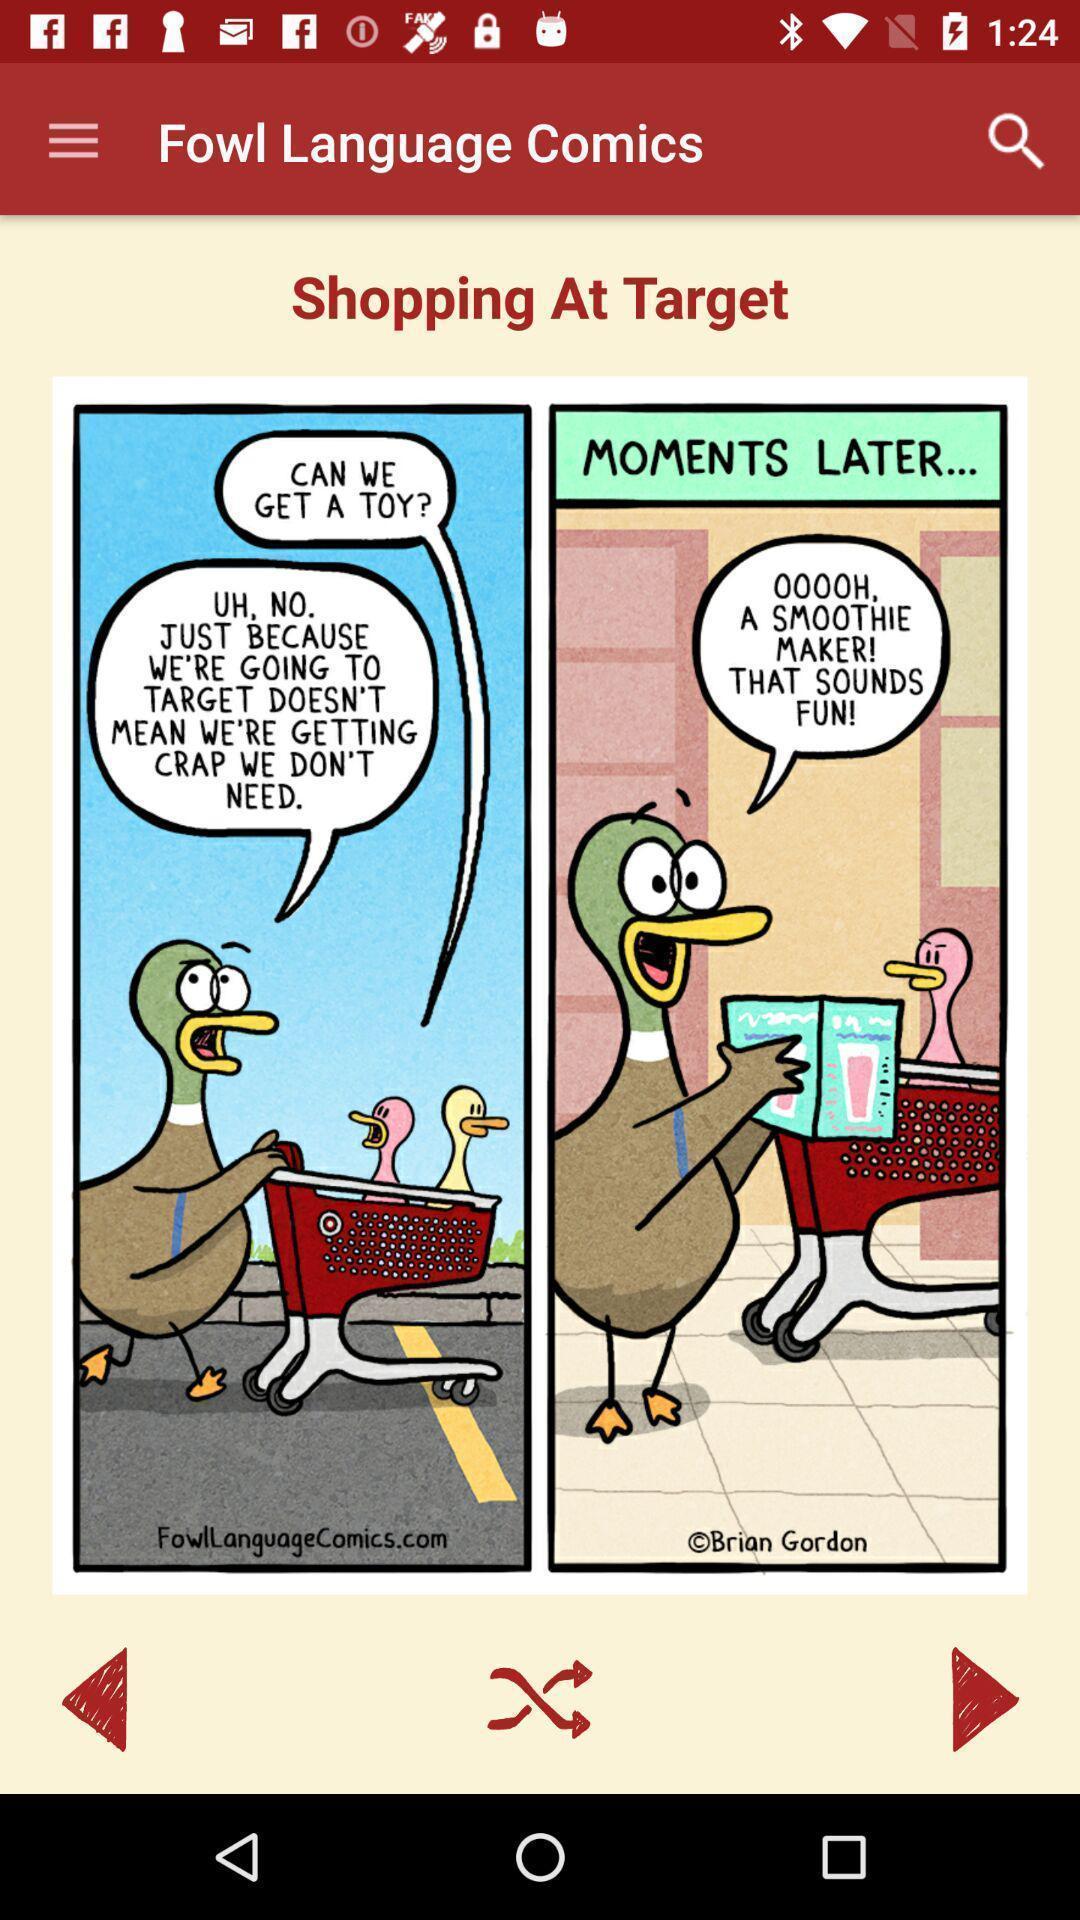Summarize the main components in this picture. Screen showing page of an comic. 